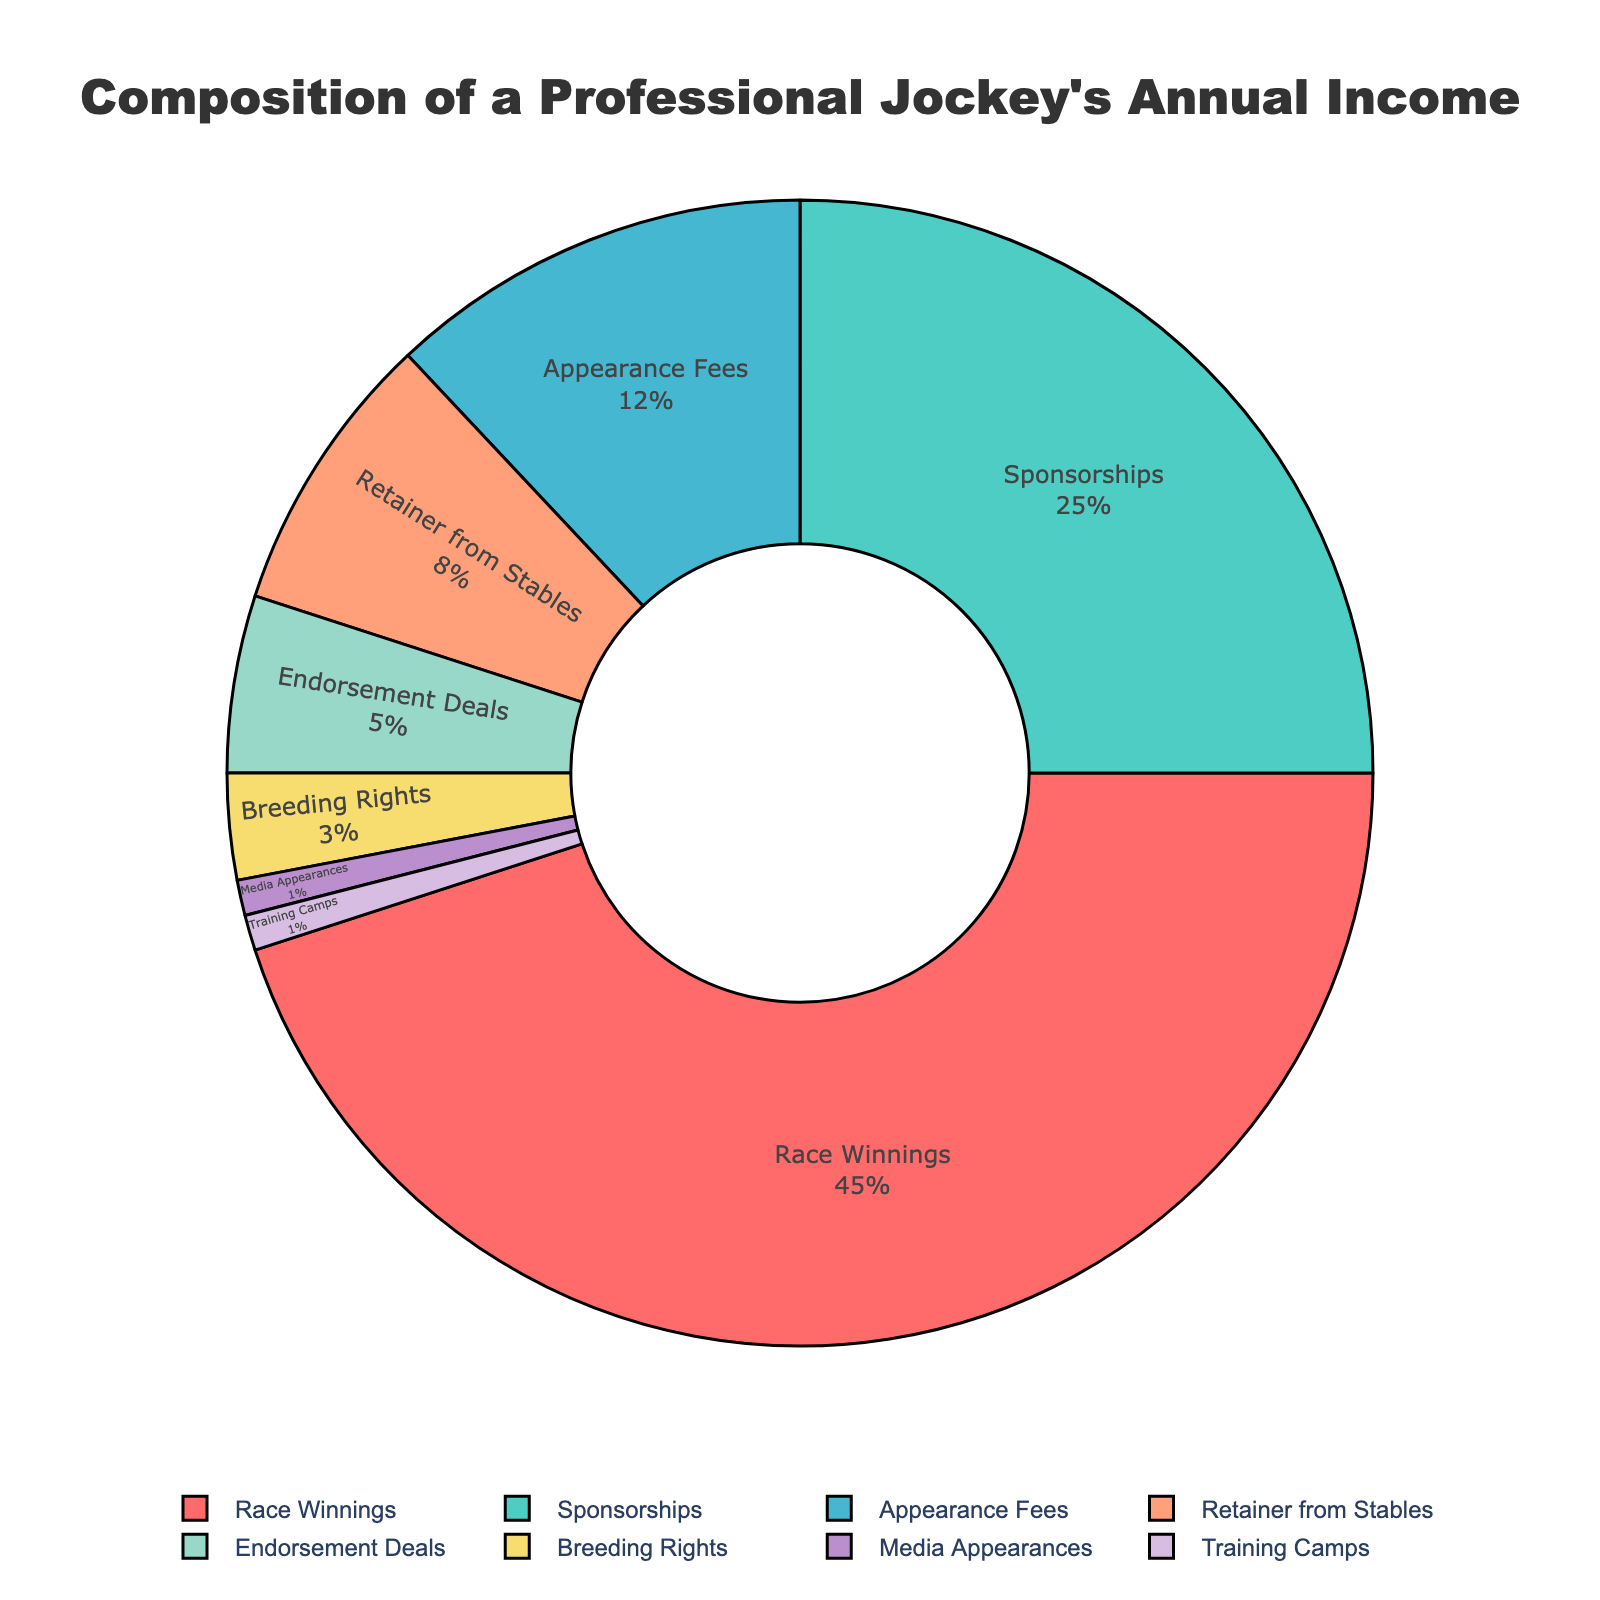What category makes up the largest portion of the jockey's annual income? To determine the largest portion of the jockey's annual income, check the slice of the pie chart that corresponds to the largest percentage. From the data, Race Winnings contribute 45%, which is the largest share.
Answer: Race Winnings How much more percentage do Race Winnings contribute compared to Sponsorships? Race Winnings contribute 45% and Sponsorships contribute 25%. Subtract the percentage of Sponsorships from Race Winnings: 45% - 25% = 20%.
Answer: 20% Which two categories combined have the smallest contribution to the annual income? To find the two smallest contributors, look for the categories with the lowest percentages. Media Appearances and Training Camps both contribute 1% each. Adding them together: 1% + 1% = 2%, which is the smallest combined contribution.
Answer: Media Appearances and Training Camps Compare the contribution of Appearance Fees to Endorsement Deals. Which one is greater and by how much? Appearance Fees contribute 12% while Endorsement Deals contribute 5%. The difference is 12% - 5% = 7%.
Answer: Appearance Fees by 7% What percentage of the jockey's income does not come from Race Winnings? Race Winnings comprise 45% of the income. Therefore, the remaining percentage is 100% - 45% = 55%.
Answer: 55% If we combine the contributions from Breeding Rights and Retainer from Stables, what would be their total percentage? Breeding Rights contribute 3% and Retainer from Stables contribute 8%. Adding them together: 3% + 8% = 11%.
Answer: 11% How does the total percentage from Sponsorships and Endorsement Deals compare to Race Winnings? Sponsorships contribute 25% and Endorsement Deals contribute 5%. Combined, they represent 25% + 5% = 30%. Comparing this to Race Winnings, which is 45%, Race Winnings are greater by 15%.
Answer: Race Winnings by 15% What category contributes the second highest percentage to the jockey's annual income? By looking at the pie chart, Sponsorships contribute 25%, which is the second highest share after Race Winnings.
Answer: Sponsorships What is the combined percentage of categories contributing less than 10% each? Categories contributing less than 10% are Retainer from Stables (8%), Endorsement Deals (5%), Breeding Rights (3%), Media Appearances (1%), and Training Camps (1%). Adding these: 8% + 5% + 3% + 1% + 1% = 18%.
Answer: 18% What is the median percentage value of all the income categories? List the percentages in ascending order: 1%, 1%, 3%, 5%, 8%, 12%, 25%, 45%. The median is the average of the 4th and 5th values: (5% + 8%)/2 = 6.5%.
Answer: 6.5% 